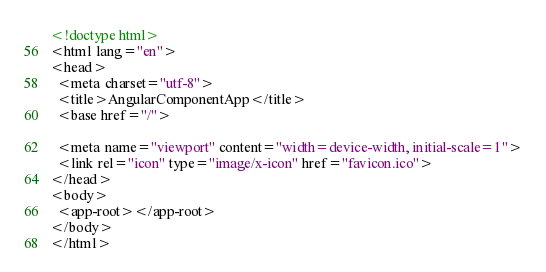Convert code to text. <code><loc_0><loc_0><loc_500><loc_500><_HTML_><!doctype html>
<html lang="en">
<head>
  <meta charset="utf-8">
  <title>AngularComponentApp</title>
  <base href="/">

  <meta name="viewport" content="width=device-width, initial-scale=1">
  <link rel="icon" type="image/x-icon" href="favicon.ico">
</head>
<body>
  <app-root></app-root>
</body>
</html>
</code> 